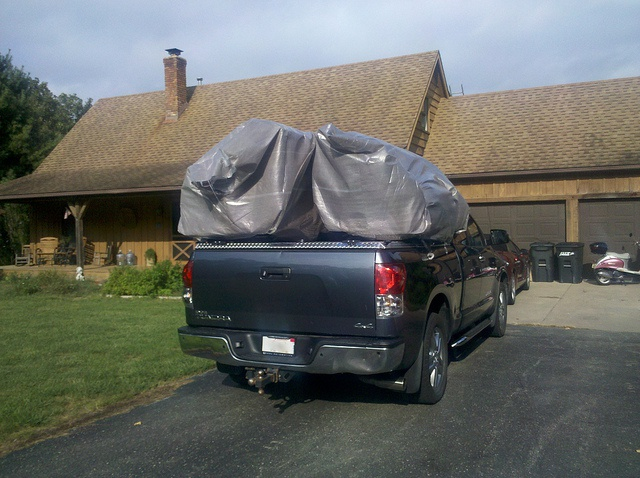Describe the objects in this image and their specific colors. I can see truck in darkgray, black, gray, and blue tones, car in darkgray, black, and gray tones, motorcycle in darkgray, gray, black, and lightgray tones, chair in darkgray, olive, and tan tones, and chair in darkgray, olive, black, and gray tones in this image. 